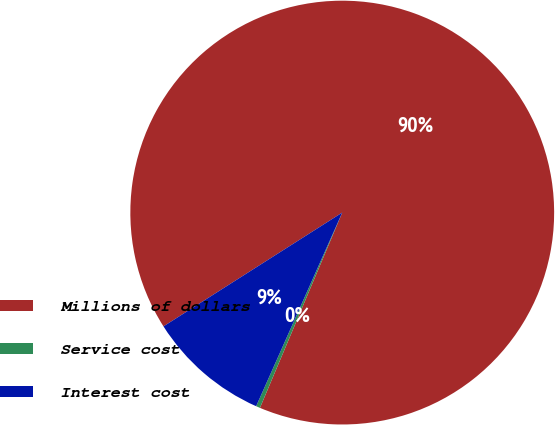Convert chart. <chart><loc_0><loc_0><loc_500><loc_500><pie_chart><fcel>Millions of dollars<fcel>Service cost<fcel>Interest cost<nl><fcel>90.37%<fcel>0.31%<fcel>9.32%<nl></chart> 